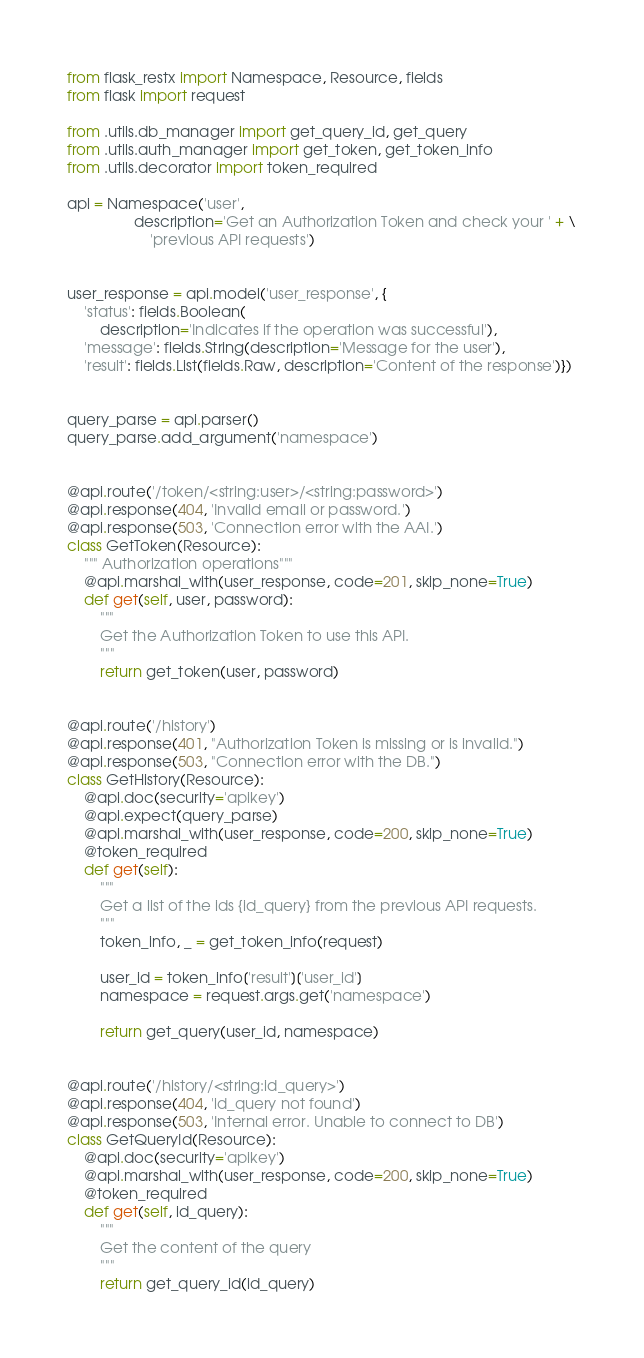<code> <loc_0><loc_0><loc_500><loc_500><_Python_>from flask_restx import Namespace, Resource, fields
from flask import request

from .utils.db_manager import get_query_id, get_query
from .utils.auth_manager import get_token, get_token_info
from .utils.decorator import token_required

api = Namespace('user',
                description='Get an Authorization Token and check your ' + \
                    'previous API requests')


user_response = api.model('user_response', {
    'status': fields.Boolean(
        description='Indicates if the operation was successful'),
    'message': fields.String(description='Message for the user'),
    'result': fields.List(fields.Raw, description='Content of the response')})


query_parse = api.parser()
query_parse.add_argument('namespace')


@api.route('/token/<string:user>/<string:password>')
@api.response(404, 'Invalid email or password.')
@api.response(503, 'Connection error with the AAI.')
class GetToken(Resource):
    """ Authorization operations"""
    @api.marshal_with(user_response, code=201, skip_none=True)
    def get(self, user, password):
        """
        Get the Authorization Token to use this API.
        """
        return get_token(user, password)


@api.route('/history')
@api.response(401, "Authorization Token is missing or is invalid.")
@api.response(503, "Connection error with the DB.")
class GetHistory(Resource):
    @api.doc(security='apikey')
    @api.expect(query_parse)
    @api.marshal_with(user_response, code=200, skip_none=True)
    @token_required
    def get(self):
        """
        Get a list of the ids {id_query} from the previous API requests.
        """
        token_info, _ = get_token_info(request)

        user_id = token_info['result']['user_id']
        namespace = request.args.get('namespace')

        return get_query(user_id, namespace)


@api.route('/history/<string:id_query>')
@api.response(404, 'id_query not found')
@api.response(503, 'Internal error. Unable to connect to DB')
class GetQueryId(Resource):
    @api.doc(security='apikey')
    @api.marshal_with(user_response, code=200, skip_none=True)
    @token_required
    def get(self, id_query):
        """
        Get the content of the query
        """
        return get_query_id(id_query)
</code> 